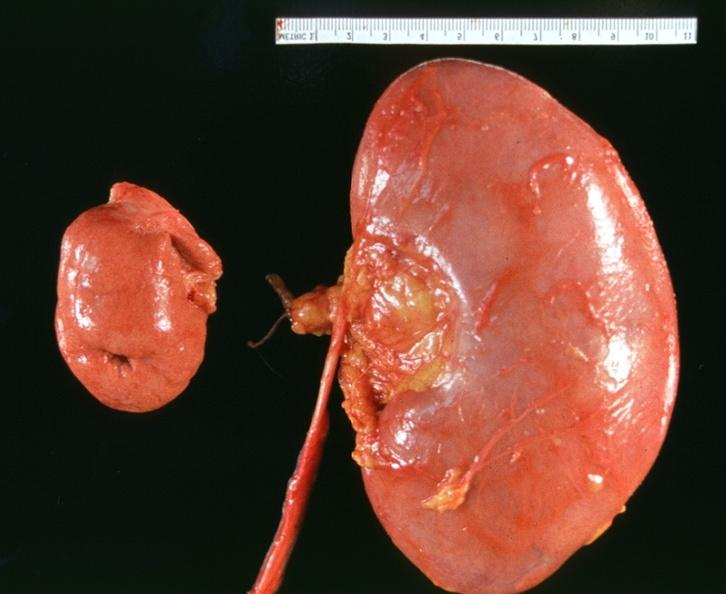what does this image show?
Answer the question using a single word or phrase. Hyoplasia of kidney 